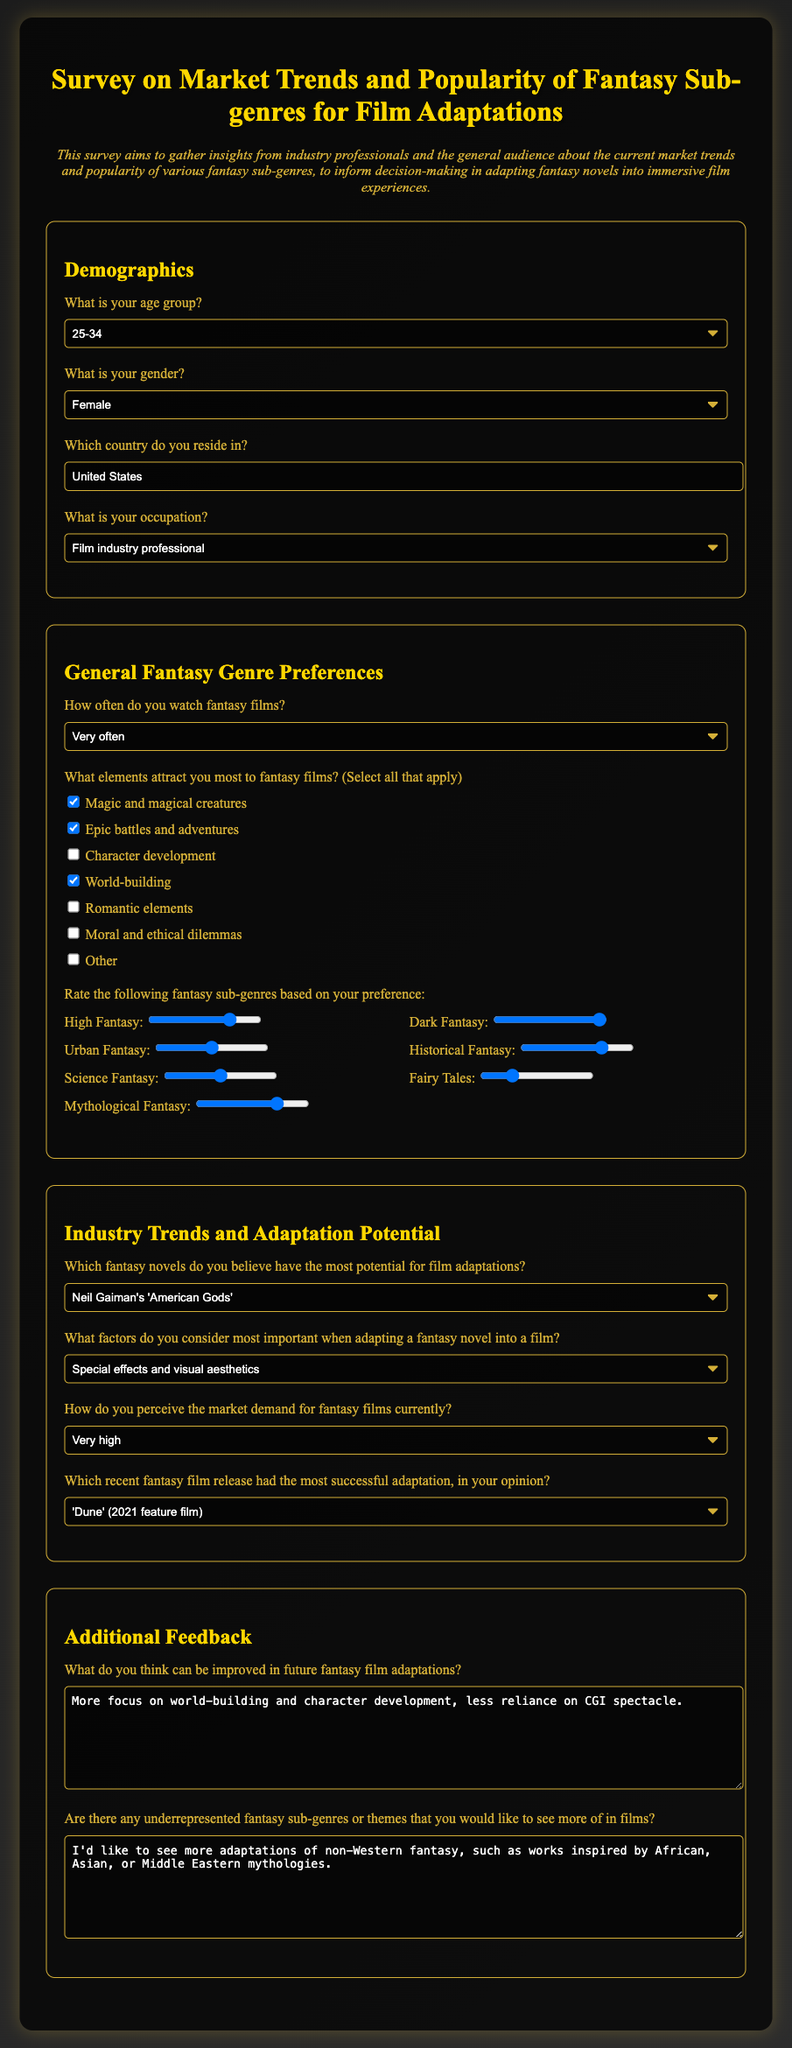What is the title of the survey? The title is found at the top of the document, indicating the survey's focus.
Answer: Survey on Market Trends and Popularity of Fantasy Sub-genres for Film Adaptations Which novel is selected as having the most adaptation potential? The selected option in the adaptation potential section indicates the respondent's choice for a novel with high adaptation potential.
Answer: Neil Gaiman's 'American Gods' How often do participants watch fantasy films? The selected option in the watch frequency question reveals how frequently participants engage with fantasy films.
Answer: Very often What is the age group of the respondents? The options include various age ranges, and a selected option reflects the respondent's age group.
Answer: 25-34 Which recent fantasy film was considered the most successful adaptation? The selected option in the successful adaptation section indicates the respondent's opinion on recent adaptations.
Answer: 'Dune' (2021 feature film) What element is checked as a preferred attraction to fantasy films? The checked options in the elements section reveal specific attractions participants have towards fantasy films.
Answer: Magic and magical creatures What improvement do participants suggest for future fantasy film adaptations? The textarea in the feedback section contains specific suggestions from respondents on how to enhance adaptations.
Answer: More focus on world-building and character development, less reliance on CGI spectacle What fantasy sub-genre received the highest rating preference in the survey? The ratings section contains ranges that indicate the level of preference for each fantasy sub-genre.
Answer: Dark Fantasy 